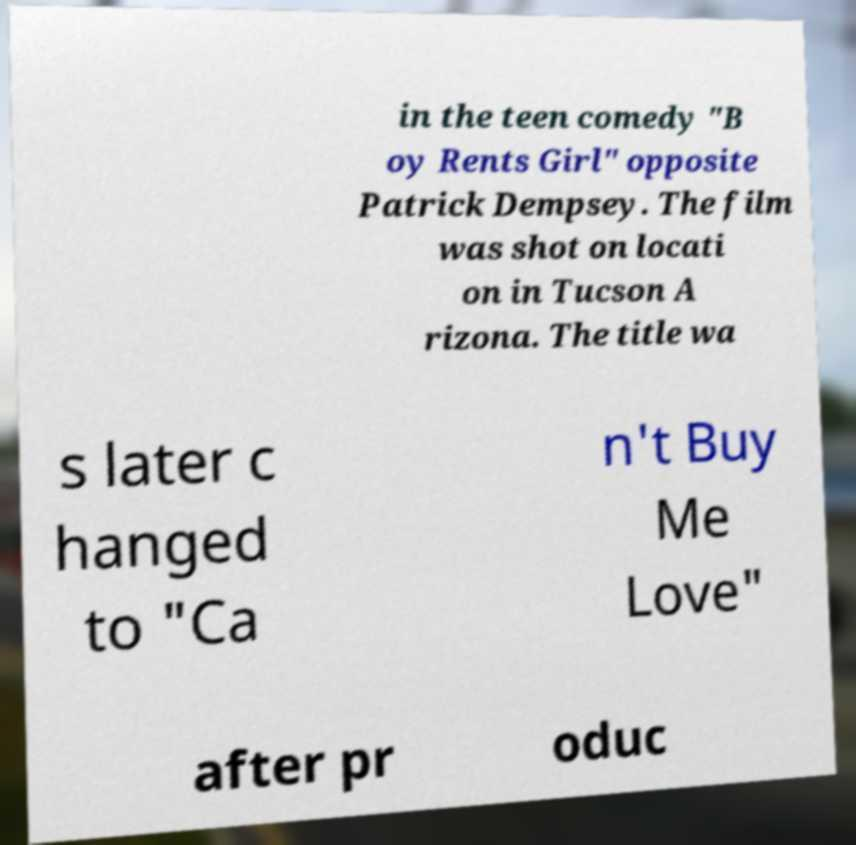Could you assist in decoding the text presented in this image and type it out clearly? in the teen comedy "B oy Rents Girl" opposite Patrick Dempsey. The film was shot on locati on in Tucson A rizona. The title wa s later c hanged to "Ca n't Buy Me Love" after pr oduc 